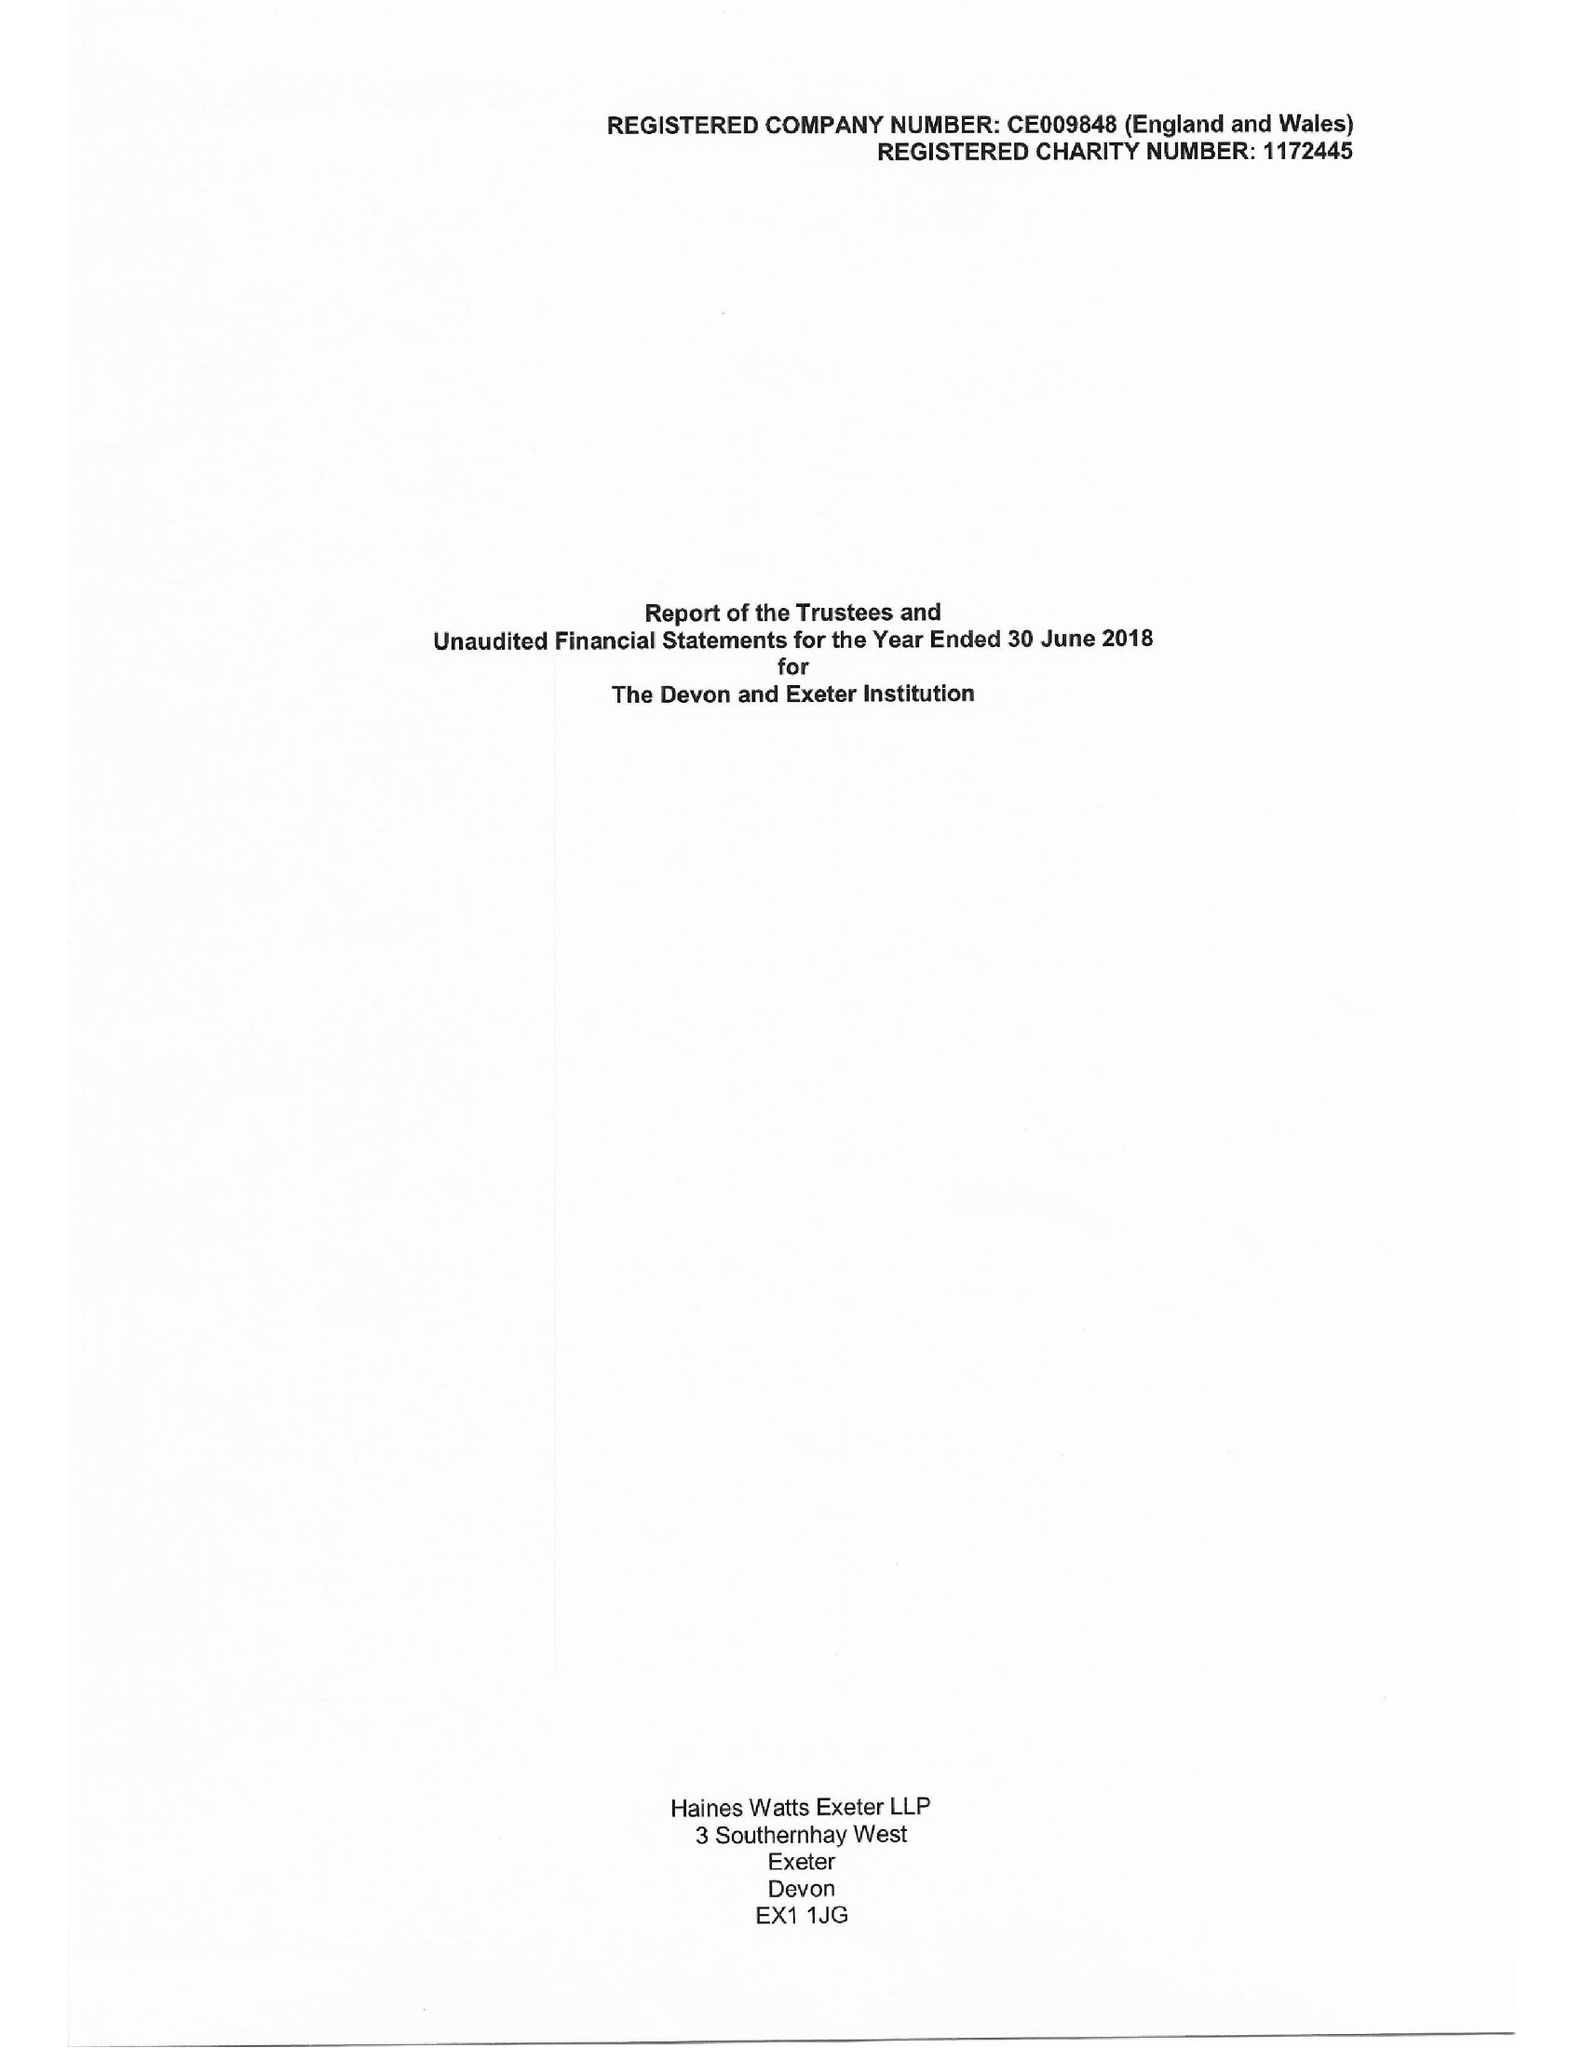What is the value for the spending_annually_in_british_pounds?
Answer the question using a single word or phrase. 230460.00 